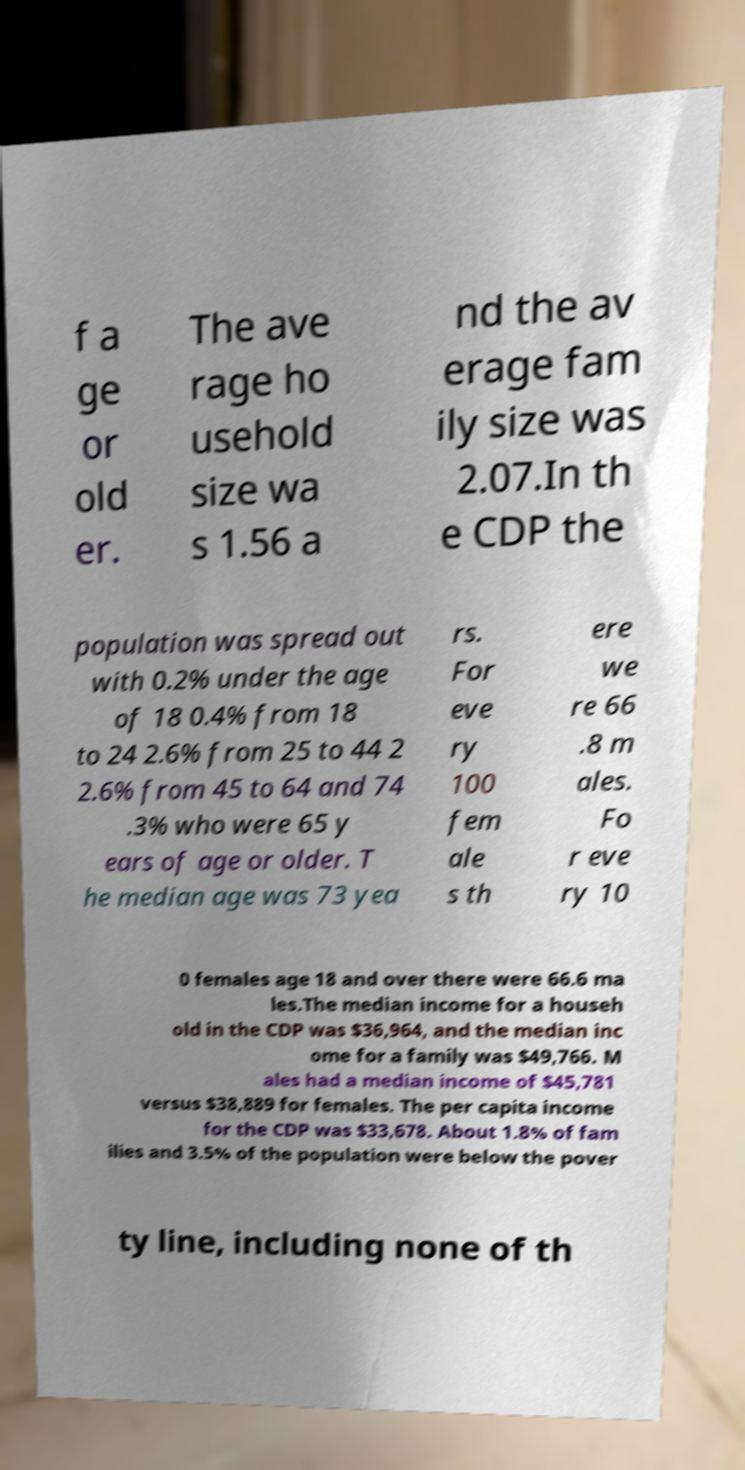Can you accurately transcribe the text from the provided image for me? f a ge or old er. The ave rage ho usehold size wa s 1.56 a nd the av erage fam ily size was 2.07.In th e CDP the population was spread out with 0.2% under the age of 18 0.4% from 18 to 24 2.6% from 25 to 44 2 2.6% from 45 to 64 and 74 .3% who were 65 y ears of age or older. T he median age was 73 yea rs. For eve ry 100 fem ale s th ere we re 66 .8 m ales. Fo r eve ry 10 0 females age 18 and over there were 66.6 ma les.The median income for a househ old in the CDP was $36,964, and the median inc ome for a family was $49,766. M ales had a median income of $45,781 versus $38,889 for females. The per capita income for the CDP was $33,678. About 1.8% of fam ilies and 3.5% of the population were below the pover ty line, including none of th 